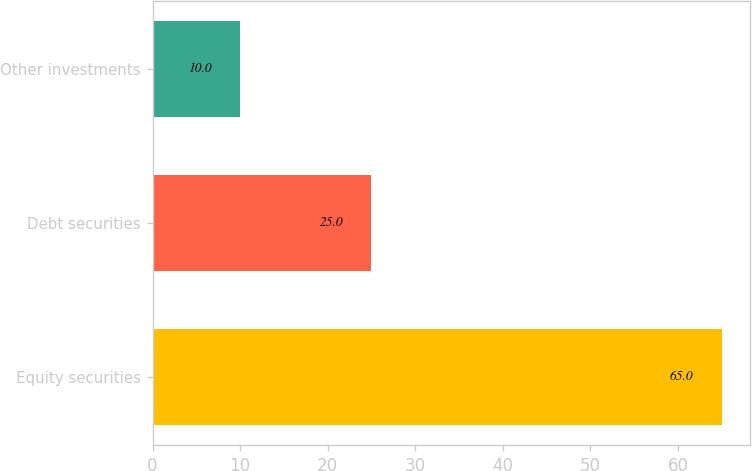Convert chart. <chart><loc_0><loc_0><loc_500><loc_500><bar_chart><fcel>Equity securities<fcel>Debt securities<fcel>Other investments<nl><fcel>65<fcel>25<fcel>10<nl></chart> 